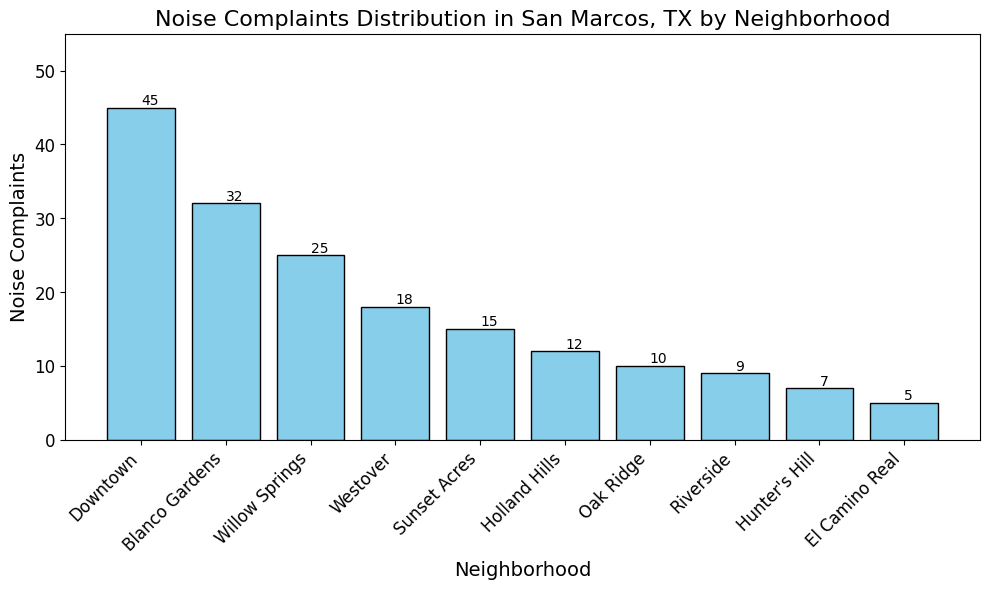Which neighborhood has the highest number of noise complaints? The neighborhood with the highest bar in the chart represents the highest number of noise complaints. Downtown San Marcos has the highest bar.
Answer: Downtown What is the total number of noise complaints from the three neighborhoods with the most complaints? Identify the top three neighborhoods: Downtown, Blanco Gardens, and Willow Springs. Add their noise complaints: 45 (Downtown) + 32 (Blanco Gardens) + 25 (Willow Springs) = 102.
Answer: 102 How many more noise complaints does Downtown have compared to Westover? Find the difference between complaints in Downtown (45) and Westover (18): 45 - 18 = 27.
Answer: 27 Which neighborhood has fewer noise complaints, Hunter's Hill or Oak Ridge? Compare the height of the bars for Hunter's Hill (7) and Oak Ridge (10): Hunter's Hill has fewer complaints.
Answer: Hunter's Hill What is the average number of noise complaints across all neighborhoods listed? Sum all noise complaints and divide by the number of neighborhoods: (45 + 32 + 25 + 18 + 15 + 12 + 10 + 9 + 7 + 5) = 178. Divide 178 by 10 (the number of neighborhoods) to get the average:  178 ÷ 10 = 17.8.
Answer: 17.8 What is the sum of noise complaints for neighborhoods with less than 20 complaints? Identify neighborhoods with less than 20 complaints, then sum their complaints: Westover (18) + Sunset Acres (15) + Holland Hills (12) + Oak Ridge (10) + Riverside (9) + Hunter's Hill (7) + El Camino Real (5) = 76.
Answer: 76 Is the number of noise complaints in Willow Springs greater than or less than half the number of complaints in Downtown? Half of the complaints in Downtown is 45 / 2 = 22.5. Compare this with Willow Springs (25): 25 is greater than 22.5.
Answer: Greater Which two neighborhoods have a combined total of 22 noise complaints? Examine pairs of neighborhoods to find a combined total of 22 complaints: Holland Hills (12) + Hunter's Hill (10) = 22.
Answer: Holland Hills and Hunter's Hill By how much does Blanco Gardens exceed Sunset Acres in noise complaints? Find the difference between complaints in Blanco Gardens (32) and Sunset Acres (15): 32 - 15 = 17.
Answer: 17 Rank the neighborhoods from highest to lowest in terms of noise complaints. List the neighborhoods in descending order based on the height of the bars: Downtown (45), Blanco Gardens (32), Willow Springs (25), Westover (18), Sunset Acres (15), Holland Hills (12), Oak Ridge (10), Riverside (9), Hunter's Hill (7), and El Camino Real (5).
Answer: Downtown, Blanco Gardens, Willow Springs, Westover, Sunset Acres, Holland Hills, Oak Ridge, Riverside, Hunter's Hill, El Camino Real 